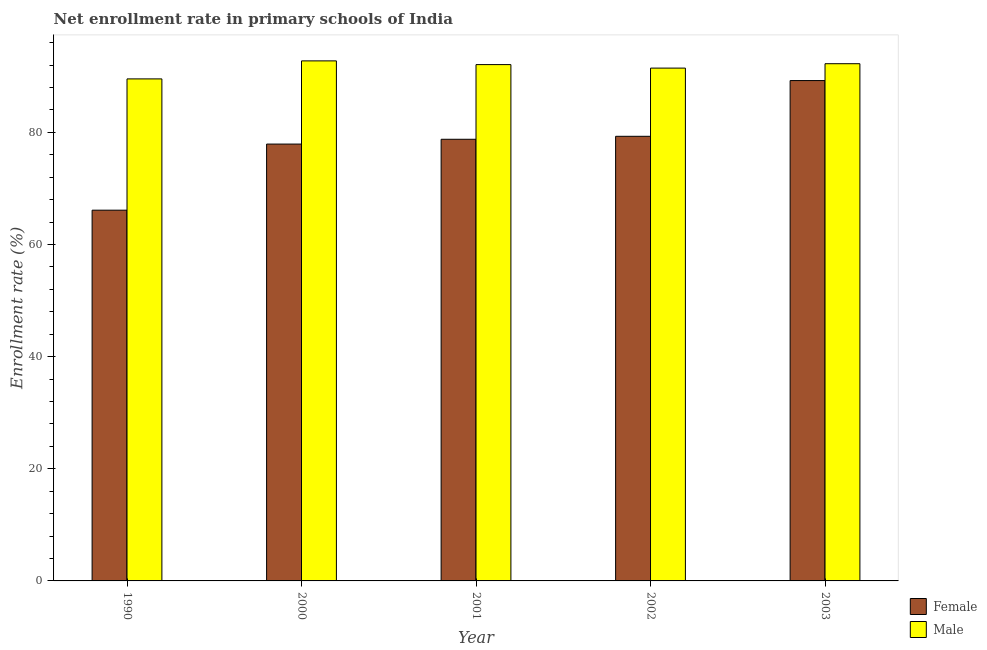How many different coloured bars are there?
Make the answer very short. 2. How many groups of bars are there?
Your response must be concise. 5. Are the number of bars per tick equal to the number of legend labels?
Your response must be concise. Yes. Are the number of bars on each tick of the X-axis equal?
Offer a terse response. Yes. How many bars are there on the 5th tick from the left?
Make the answer very short. 2. How many bars are there on the 4th tick from the right?
Offer a very short reply. 2. What is the label of the 4th group of bars from the left?
Provide a succinct answer. 2002. What is the enrollment rate of male students in 2003?
Your answer should be compact. 92.23. Across all years, what is the maximum enrollment rate of female students?
Provide a short and direct response. 89.22. Across all years, what is the minimum enrollment rate of male students?
Your answer should be compact. 89.52. In which year was the enrollment rate of male students minimum?
Your response must be concise. 1990. What is the total enrollment rate of male students in the graph?
Offer a terse response. 458.01. What is the difference between the enrollment rate of female students in 2000 and that in 2002?
Keep it short and to the point. -1.39. What is the difference between the enrollment rate of female students in 2000 and the enrollment rate of male students in 2003?
Keep it short and to the point. -11.32. What is the average enrollment rate of male students per year?
Keep it short and to the point. 91.6. What is the ratio of the enrollment rate of female students in 2000 to that in 2002?
Provide a succinct answer. 0.98. Is the enrollment rate of male students in 2000 less than that in 2003?
Ensure brevity in your answer.  No. Is the difference between the enrollment rate of female students in 2001 and 2003 greater than the difference between the enrollment rate of male students in 2001 and 2003?
Your answer should be compact. No. What is the difference between the highest and the second highest enrollment rate of female students?
Your answer should be very brief. 9.94. What is the difference between the highest and the lowest enrollment rate of male students?
Provide a succinct answer. 3.21. In how many years, is the enrollment rate of female students greater than the average enrollment rate of female students taken over all years?
Your response must be concise. 3. What does the 2nd bar from the left in 2001 represents?
Ensure brevity in your answer.  Male. Does the graph contain grids?
Offer a very short reply. No. Where does the legend appear in the graph?
Keep it short and to the point. Bottom right. How many legend labels are there?
Make the answer very short. 2. How are the legend labels stacked?
Your answer should be compact. Vertical. What is the title of the graph?
Make the answer very short. Net enrollment rate in primary schools of India. What is the label or title of the Y-axis?
Offer a very short reply. Enrollment rate (%). What is the Enrollment rate (%) of Female in 1990?
Provide a succinct answer. 66.11. What is the Enrollment rate (%) in Male in 1990?
Give a very brief answer. 89.52. What is the Enrollment rate (%) in Female in 2000?
Provide a succinct answer. 77.9. What is the Enrollment rate (%) in Male in 2000?
Make the answer very short. 92.74. What is the Enrollment rate (%) of Female in 2001?
Your answer should be very brief. 78.75. What is the Enrollment rate (%) in Male in 2001?
Give a very brief answer. 92.07. What is the Enrollment rate (%) of Female in 2002?
Ensure brevity in your answer.  79.29. What is the Enrollment rate (%) of Male in 2002?
Your answer should be compact. 91.45. What is the Enrollment rate (%) of Female in 2003?
Your response must be concise. 89.22. What is the Enrollment rate (%) in Male in 2003?
Provide a short and direct response. 92.23. Across all years, what is the maximum Enrollment rate (%) in Female?
Ensure brevity in your answer.  89.22. Across all years, what is the maximum Enrollment rate (%) in Male?
Offer a terse response. 92.74. Across all years, what is the minimum Enrollment rate (%) of Female?
Ensure brevity in your answer.  66.11. Across all years, what is the minimum Enrollment rate (%) in Male?
Offer a terse response. 89.52. What is the total Enrollment rate (%) of Female in the graph?
Your answer should be compact. 391.28. What is the total Enrollment rate (%) in Male in the graph?
Ensure brevity in your answer.  458. What is the difference between the Enrollment rate (%) of Female in 1990 and that in 2000?
Make the answer very short. -11.79. What is the difference between the Enrollment rate (%) of Male in 1990 and that in 2000?
Make the answer very short. -3.21. What is the difference between the Enrollment rate (%) in Female in 1990 and that in 2001?
Your answer should be very brief. -12.64. What is the difference between the Enrollment rate (%) of Male in 1990 and that in 2001?
Provide a succinct answer. -2.55. What is the difference between the Enrollment rate (%) of Female in 1990 and that in 2002?
Your response must be concise. -13.17. What is the difference between the Enrollment rate (%) in Male in 1990 and that in 2002?
Your answer should be compact. -1.92. What is the difference between the Enrollment rate (%) of Female in 1990 and that in 2003?
Give a very brief answer. -23.11. What is the difference between the Enrollment rate (%) in Male in 1990 and that in 2003?
Offer a terse response. -2.71. What is the difference between the Enrollment rate (%) in Female in 2000 and that in 2001?
Your response must be concise. -0.85. What is the difference between the Enrollment rate (%) of Male in 2000 and that in 2001?
Your answer should be very brief. 0.67. What is the difference between the Enrollment rate (%) of Female in 2000 and that in 2002?
Give a very brief answer. -1.39. What is the difference between the Enrollment rate (%) in Male in 2000 and that in 2002?
Offer a terse response. 1.29. What is the difference between the Enrollment rate (%) in Female in 2000 and that in 2003?
Your answer should be compact. -11.32. What is the difference between the Enrollment rate (%) in Male in 2000 and that in 2003?
Offer a very short reply. 0.51. What is the difference between the Enrollment rate (%) of Female in 2001 and that in 2002?
Provide a short and direct response. -0.53. What is the difference between the Enrollment rate (%) of Male in 2001 and that in 2002?
Make the answer very short. 0.62. What is the difference between the Enrollment rate (%) of Female in 2001 and that in 2003?
Your answer should be very brief. -10.47. What is the difference between the Enrollment rate (%) of Male in 2001 and that in 2003?
Keep it short and to the point. -0.16. What is the difference between the Enrollment rate (%) of Female in 2002 and that in 2003?
Offer a terse response. -9.94. What is the difference between the Enrollment rate (%) of Male in 2002 and that in 2003?
Ensure brevity in your answer.  -0.78. What is the difference between the Enrollment rate (%) in Female in 1990 and the Enrollment rate (%) in Male in 2000?
Ensure brevity in your answer.  -26.62. What is the difference between the Enrollment rate (%) of Female in 1990 and the Enrollment rate (%) of Male in 2001?
Offer a terse response. -25.96. What is the difference between the Enrollment rate (%) in Female in 1990 and the Enrollment rate (%) in Male in 2002?
Ensure brevity in your answer.  -25.34. What is the difference between the Enrollment rate (%) of Female in 1990 and the Enrollment rate (%) of Male in 2003?
Offer a terse response. -26.12. What is the difference between the Enrollment rate (%) in Female in 2000 and the Enrollment rate (%) in Male in 2001?
Your response must be concise. -14.17. What is the difference between the Enrollment rate (%) of Female in 2000 and the Enrollment rate (%) of Male in 2002?
Keep it short and to the point. -13.55. What is the difference between the Enrollment rate (%) of Female in 2000 and the Enrollment rate (%) of Male in 2003?
Your answer should be very brief. -14.33. What is the difference between the Enrollment rate (%) in Female in 2001 and the Enrollment rate (%) in Male in 2002?
Keep it short and to the point. -12.69. What is the difference between the Enrollment rate (%) in Female in 2001 and the Enrollment rate (%) in Male in 2003?
Give a very brief answer. -13.48. What is the difference between the Enrollment rate (%) of Female in 2002 and the Enrollment rate (%) of Male in 2003?
Provide a succinct answer. -12.94. What is the average Enrollment rate (%) in Female per year?
Offer a terse response. 78.26. What is the average Enrollment rate (%) in Male per year?
Your answer should be very brief. 91.6. In the year 1990, what is the difference between the Enrollment rate (%) of Female and Enrollment rate (%) of Male?
Your response must be concise. -23.41. In the year 2000, what is the difference between the Enrollment rate (%) of Female and Enrollment rate (%) of Male?
Your answer should be very brief. -14.83. In the year 2001, what is the difference between the Enrollment rate (%) of Female and Enrollment rate (%) of Male?
Make the answer very short. -13.32. In the year 2002, what is the difference between the Enrollment rate (%) of Female and Enrollment rate (%) of Male?
Ensure brevity in your answer.  -12.16. In the year 2003, what is the difference between the Enrollment rate (%) of Female and Enrollment rate (%) of Male?
Your answer should be compact. -3.01. What is the ratio of the Enrollment rate (%) in Female in 1990 to that in 2000?
Keep it short and to the point. 0.85. What is the ratio of the Enrollment rate (%) of Male in 1990 to that in 2000?
Offer a terse response. 0.97. What is the ratio of the Enrollment rate (%) in Female in 1990 to that in 2001?
Offer a terse response. 0.84. What is the ratio of the Enrollment rate (%) of Male in 1990 to that in 2001?
Your answer should be compact. 0.97. What is the ratio of the Enrollment rate (%) of Female in 1990 to that in 2002?
Your answer should be very brief. 0.83. What is the ratio of the Enrollment rate (%) of Male in 1990 to that in 2002?
Your answer should be compact. 0.98. What is the ratio of the Enrollment rate (%) in Female in 1990 to that in 2003?
Keep it short and to the point. 0.74. What is the ratio of the Enrollment rate (%) in Male in 1990 to that in 2003?
Offer a very short reply. 0.97. What is the ratio of the Enrollment rate (%) in Female in 2000 to that in 2001?
Give a very brief answer. 0.99. What is the ratio of the Enrollment rate (%) in Male in 2000 to that in 2001?
Your answer should be compact. 1.01. What is the ratio of the Enrollment rate (%) in Female in 2000 to that in 2002?
Provide a succinct answer. 0.98. What is the ratio of the Enrollment rate (%) in Male in 2000 to that in 2002?
Your answer should be very brief. 1.01. What is the ratio of the Enrollment rate (%) in Female in 2000 to that in 2003?
Offer a very short reply. 0.87. What is the ratio of the Enrollment rate (%) of Female in 2001 to that in 2002?
Your answer should be very brief. 0.99. What is the ratio of the Enrollment rate (%) of Male in 2001 to that in 2002?
Your response must be concise. 1.01. What is the ratio of the Enrollment rate (%) in Female in 2001 to that in 2003?
Your response must be concise. 0.88. What is the ratio of the Enrollment rate (%) of Female in 2002 to that in 2003?
Your answer should be compact. 0.89. What is the difference between the highest and the second highest Enrollment rate (%) of Female?
Provide a succinct answer. 9.94. What is the difference between the highest and the second highest Enrollment rate (%) in Male?
Offer a terse response. 0.51. What is the difference between the highest and the lowest Enrollment rate (%) of Female?
Offer a terse response. 23.11. What is the difference between the highest and the lowest Enrollment rate (%) of Male?
Your answer should be compact. 3.21. 